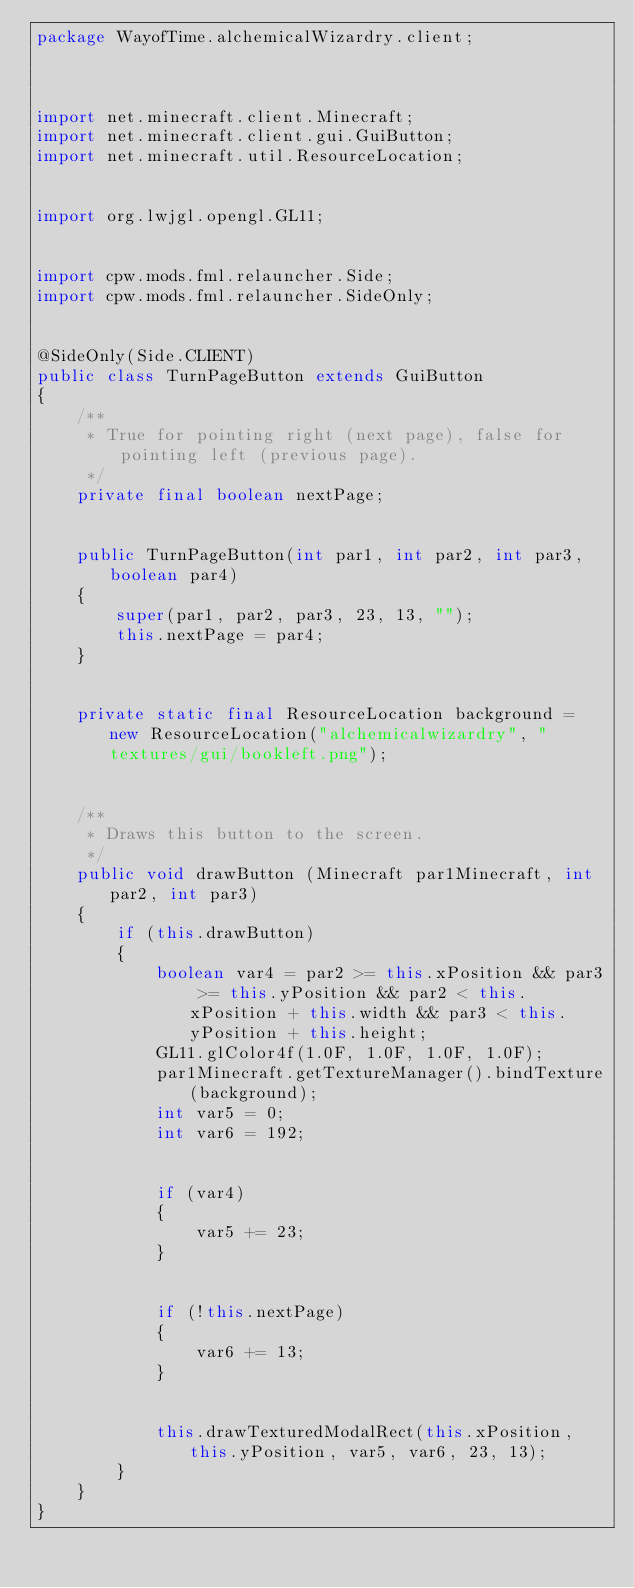<code> <loc_0><loc_0><loc_500><loc_500><_Java_>package WayofTime.alchemicalWizardry.client;



import net.minecraft.client.Minecraft;
import net.minecraft.client.gui.GuiButton;
import net.minecraft.util.ResourceLocation;


import org.lwjgl.opengl.GL11;


import cpw.mods.fml.relauncher.Side;
import cpw.mods.fml.relauncher.SideOnly;


@SideOnly(Side.CLIENT)
public class TurnPageButton extends GuiButton
{
    /**
     * True for pointing right (next page), false for pointing left (previous page).
     */
    private final boolean nextPage;


    public TurnPageButton(int par1, int par2, int par3, boolean par4)
    {
        super(par1, par2, par3, 23, 13, "");
        this.nextPage = par4;
    }


    private static final ResourceLocation background = new ResourceLocation("alchemicalwizardry", "textures/gui/bookleft.png");


    /**
     * Draws this button to the screen.
     */
    public void drawButton (Minecraft par1Minecraft, int par2, int par3)
    {
        if (this.drawButton)
        {
            boolean var4 = par2 >= this.xPosition && par3 >= this.yPosition && par2 < this.xPosition + this.width && par3 < this.yPosition + this.height;
            GL11.glColor4f(1.0F, 1.0F, 1.0F, 1.0F);
            par1Minecraft.getTextureManager().bindTexture(background);
            int var5 = 0;
            int var6 = 192;


            if (var4)
            {
                var5 += 23;
            }


            if (!this.nextPage)
            {
                var6 += 13;
            }


            this.drawTexturedModalRect(this.xPosition, this.yPosition, var5, var6, 23, 13);
        }
    }
}
</code> 